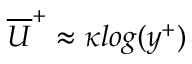Convert formula to latex. <formula><loc_0><loc_0><loc_500><loc_500>\overline { U } ^ { + } \approx \kappa \log ( y ^ { + } )</formula> 